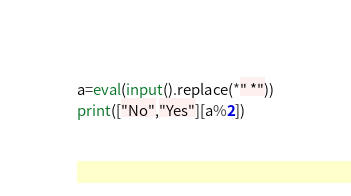Convert code to text. <code><loc_0><loc_0><loc_500><loc_500><_Python_>a=eval(input().replace(*" *"))
print(["No","Yes"][a%2])</code> 